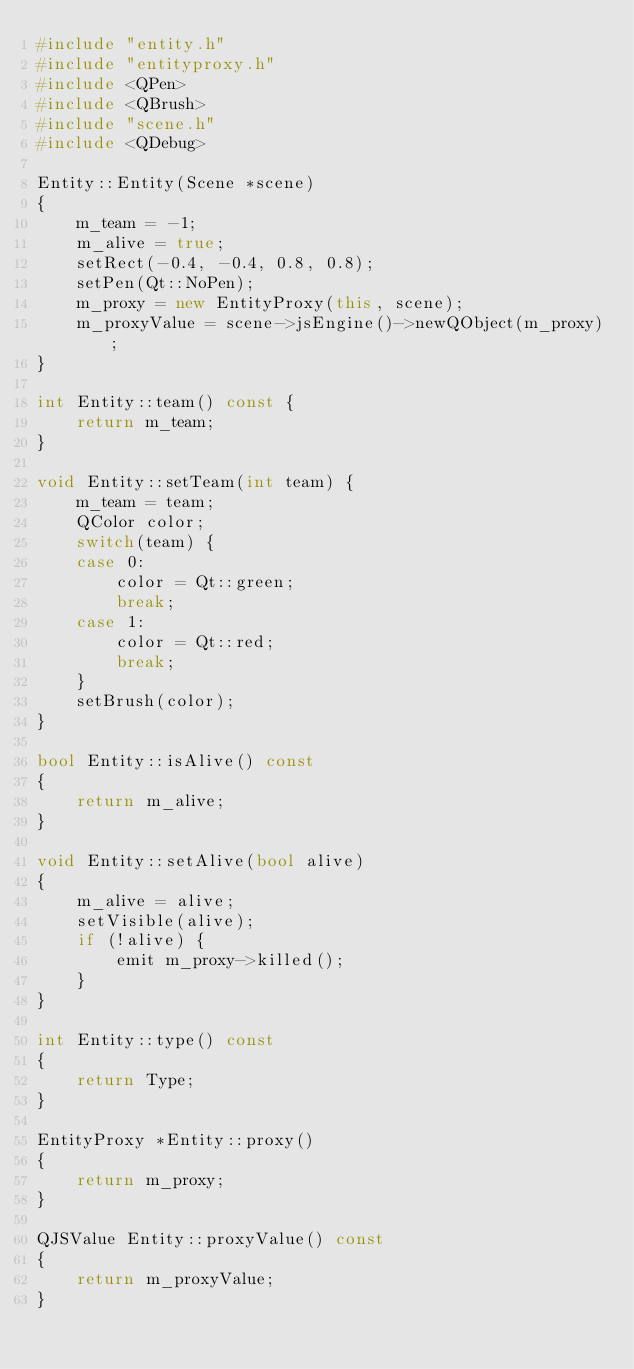Convert code to text. <code><loc_0><loc_0><loc_500><loc_500><_C++_>#include "entity.h"
#include "entityproxy.h"
#include <QPen>
#include <QBrush>
#include "scene.h"
#include <QDebug>

Entity::Entity(Scene *scene)
{
    m_team = -1;
    m_alive = true;
    setRect(-0.4, -0.4, 0.8, 0.8);
    setPen(Qt::NoPen);
    m_proxy = new EntityProxy(this, scene);
    m_proxyValue = scene->jsEngine()->newQObject(m_proxy);
}

int Entity::team() const {
    return m_team;
}

void Entity::setTeam(int team) {
    m_team = team;
    QColor color;
    switch(team) {
    case 0:
        color = Qt::green;
        break;
    case 1:
        color = Qt::red;
        break;
    }
    setBrush(color);
}

bool Entity::isAlive() const
{
    return m_alive;
}

void Entity::setAlive(bool alive)
{
    m_alive = alive;
    setVisible(alive);
    if (!alive) {
        emit m_proxy->killed();
    }
}

int Entity::type() const
{
    return Type;
}

EntityProxy *Entity::proxy()
{
    return m_proxy;
}

QJSValue Entity::proxyValue() const
{
    return m_proxyValue;
}
</code> 